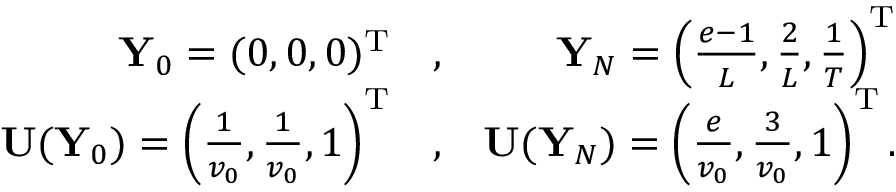Convert formula to latex. <formula><loc_0><loc_0><loc_500><loc_500>\begin{array} { r l r } { { \mathbf Y } _ { 0 } = ( 0 , 0 , 0 ) ^ { \mathrm T } } & , } & { { \mathbf Y } _ { N } = \left ( \frac { e - 1 } { L } , \frac { 2 } { L } , \frac { 1 } { T } \right ) ^ { \mathrm T } } \\ { { \mathbf U } ( { \mathbf Y } _ { 0 } ) = \left ( \frac { 1 } { v _ { 0 } } , \frac { 1 } { v _ { 0 } } , 1 \right ) ^ { \mathrm T } } & , } & { { \mathbf U } ( { \mathbf Y } _ { N } ) = \left ( \frac { e } { v _ { 0 } } , \frac { 3 } { v _ { 0 } } , 1 \right ) ^ { \mathrm T } . } \end{array}</formula> 